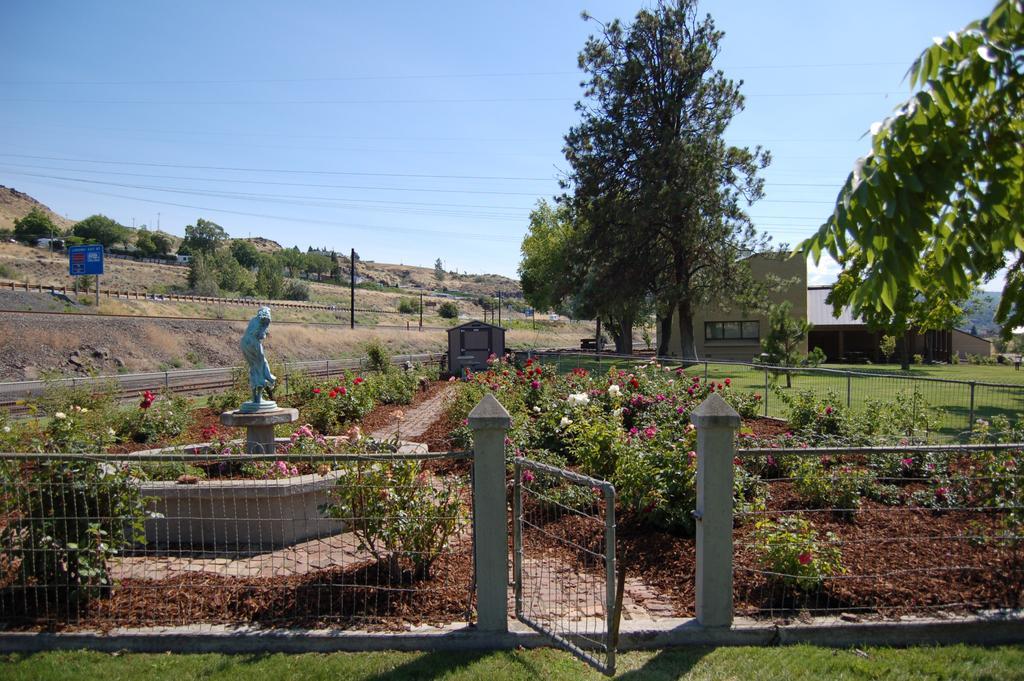Please provide a concise description of this image. In this picture we can see some plants, flowers, soil and grass at the bottom, we can see fencing and a gate in the front, in the background there is a house, trees, a pole and a board, there is the sky at the top of the picture. 